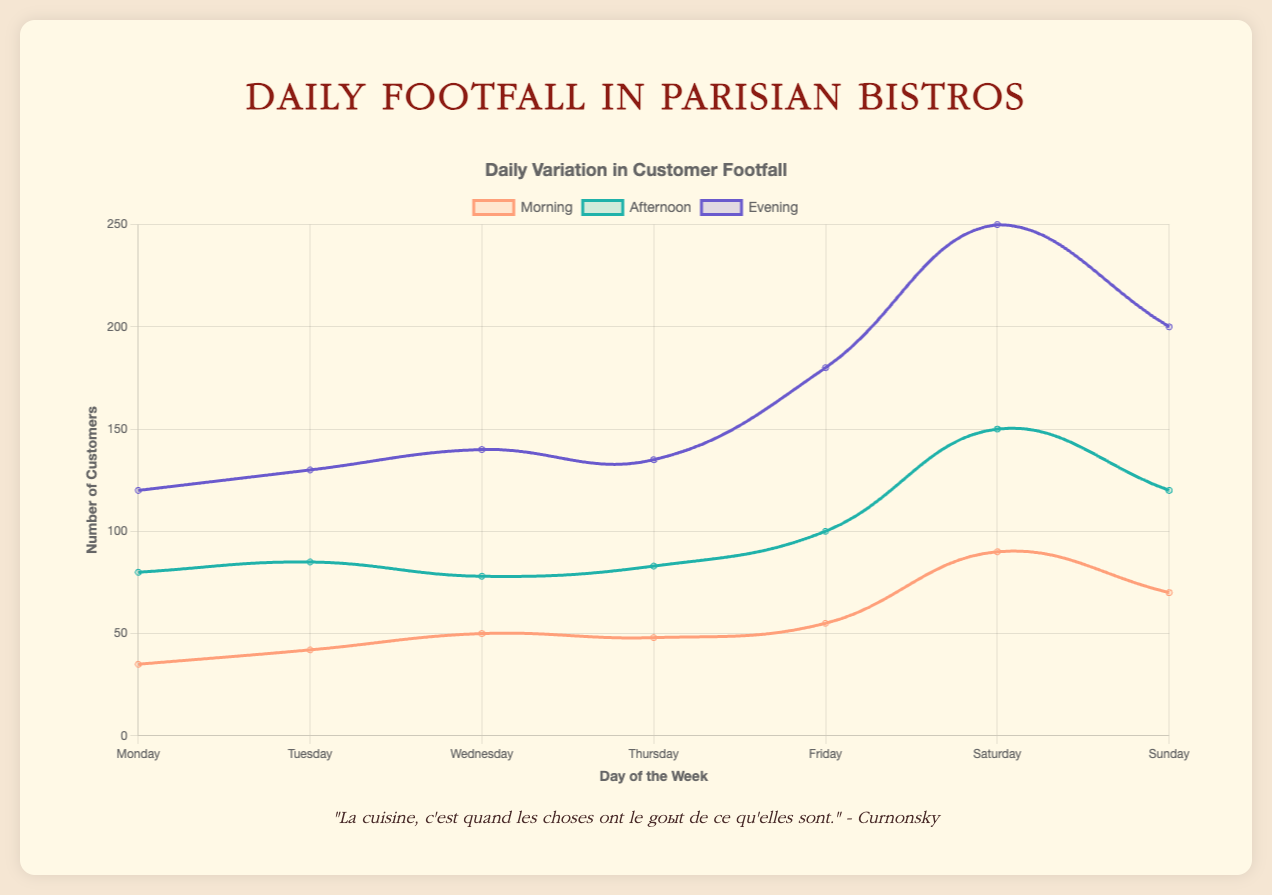Which time period has the highest footfall overall? To determine the time period with the highest footfall, we need to look at the highest values across the Morning, Afternoon, and Evening datasets. Overall, the Evening dataset has the highest values, especially on weekends.
Answer: Evening On which day is the footfall in the morning the highest? We need to examine the Morning dataset and identify the day with the highest number of customers. The highest morning footfall is on Saturday, with 90 customers.
Answer: Saturday Compare the footfall between "Le Bistro Gourmand" and "Café de la Paix" on Friday evening. Which one has more customers? Look at the Friday evening footfall values for both "Le Bistro Gourmand" (190) and "Café de la Paix" (170). "Le Bistro Gourmand" has more customers.
Answer: Le Bistro Gourmand What is the average footfall in the morning across the week? Sum the morning footfall values for all days (35 + 42 + 50 + 48 + 55 + 90 + 70 = 390) and divide by the number of days (7). The average morning footfall is 390 / 7 ≈ 55.71.
Answer: 55.71 Which day has the lowest footfall in the afternoon? Examine the Afternoon dataset and identify the day with the lowest number of customers. The lowest footfall in the afternoon is on Wednesday, with 78 customers.
Answer: Wednesday By how much does the footfall increase from Tuesday afternoon to Saturday afternoon? Subtract the footfall on Tuesday afternoon (85) from the footfall on Saturday afternoon (150). The increase is 150 - 85 = 65 customers.
Answer: 65 What is the total footfall on Sunday for "Bistro des Amis"? Sum the footfall values for Sunday in "Bistro des Amis": morning (72) + afternoon (115) + evening (195) = 72 + 115 + 195 = 382 customers.
Answer: 382 Which bistro has the most even distribution of footfall across the day on Thursday? Compare the footfall values for Morning, Afternoon, and Evening on Thursday for each bistro. "Bistro des Amis" has the values (49, 84, 132), "Le Bistro Gourmand" (50, 85, 140), and "Café de la Paix" (45, 80, 130). "Café de la Paix" has the most even distribution with values (45, 80, 130).
Answer: Café de la Paix How does the overall footfall trend change from weekday to weekend in the evenings? Compare the evening footfall values from Monday to Friday and then Saturday to Sunday. The values rise substantially from weekdays to weekends, with the highest values on Saturday and Sunday.
Answer: Increase What is the difference in footfall between the highest and lowest days of the week in the morning? Identify the highest (Saturday, 90) and lowest (Monday, 35) values in the Morning dataset and calculate the difference: 90 - 35 = 55 customers.
Answer: 55 